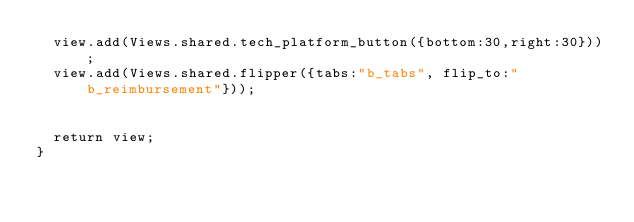<code> <loc_0><loc_0><loc_500><loc_500><_JavaScript_>	view.add(Views.shared.tech_platform_button({bottom:30,right:30}));
	view.add(Views.shared.flipper({tabs:"b_tabs", flip_to:"b_reimbursement"}));
	
	
	return view;
}
</code> 